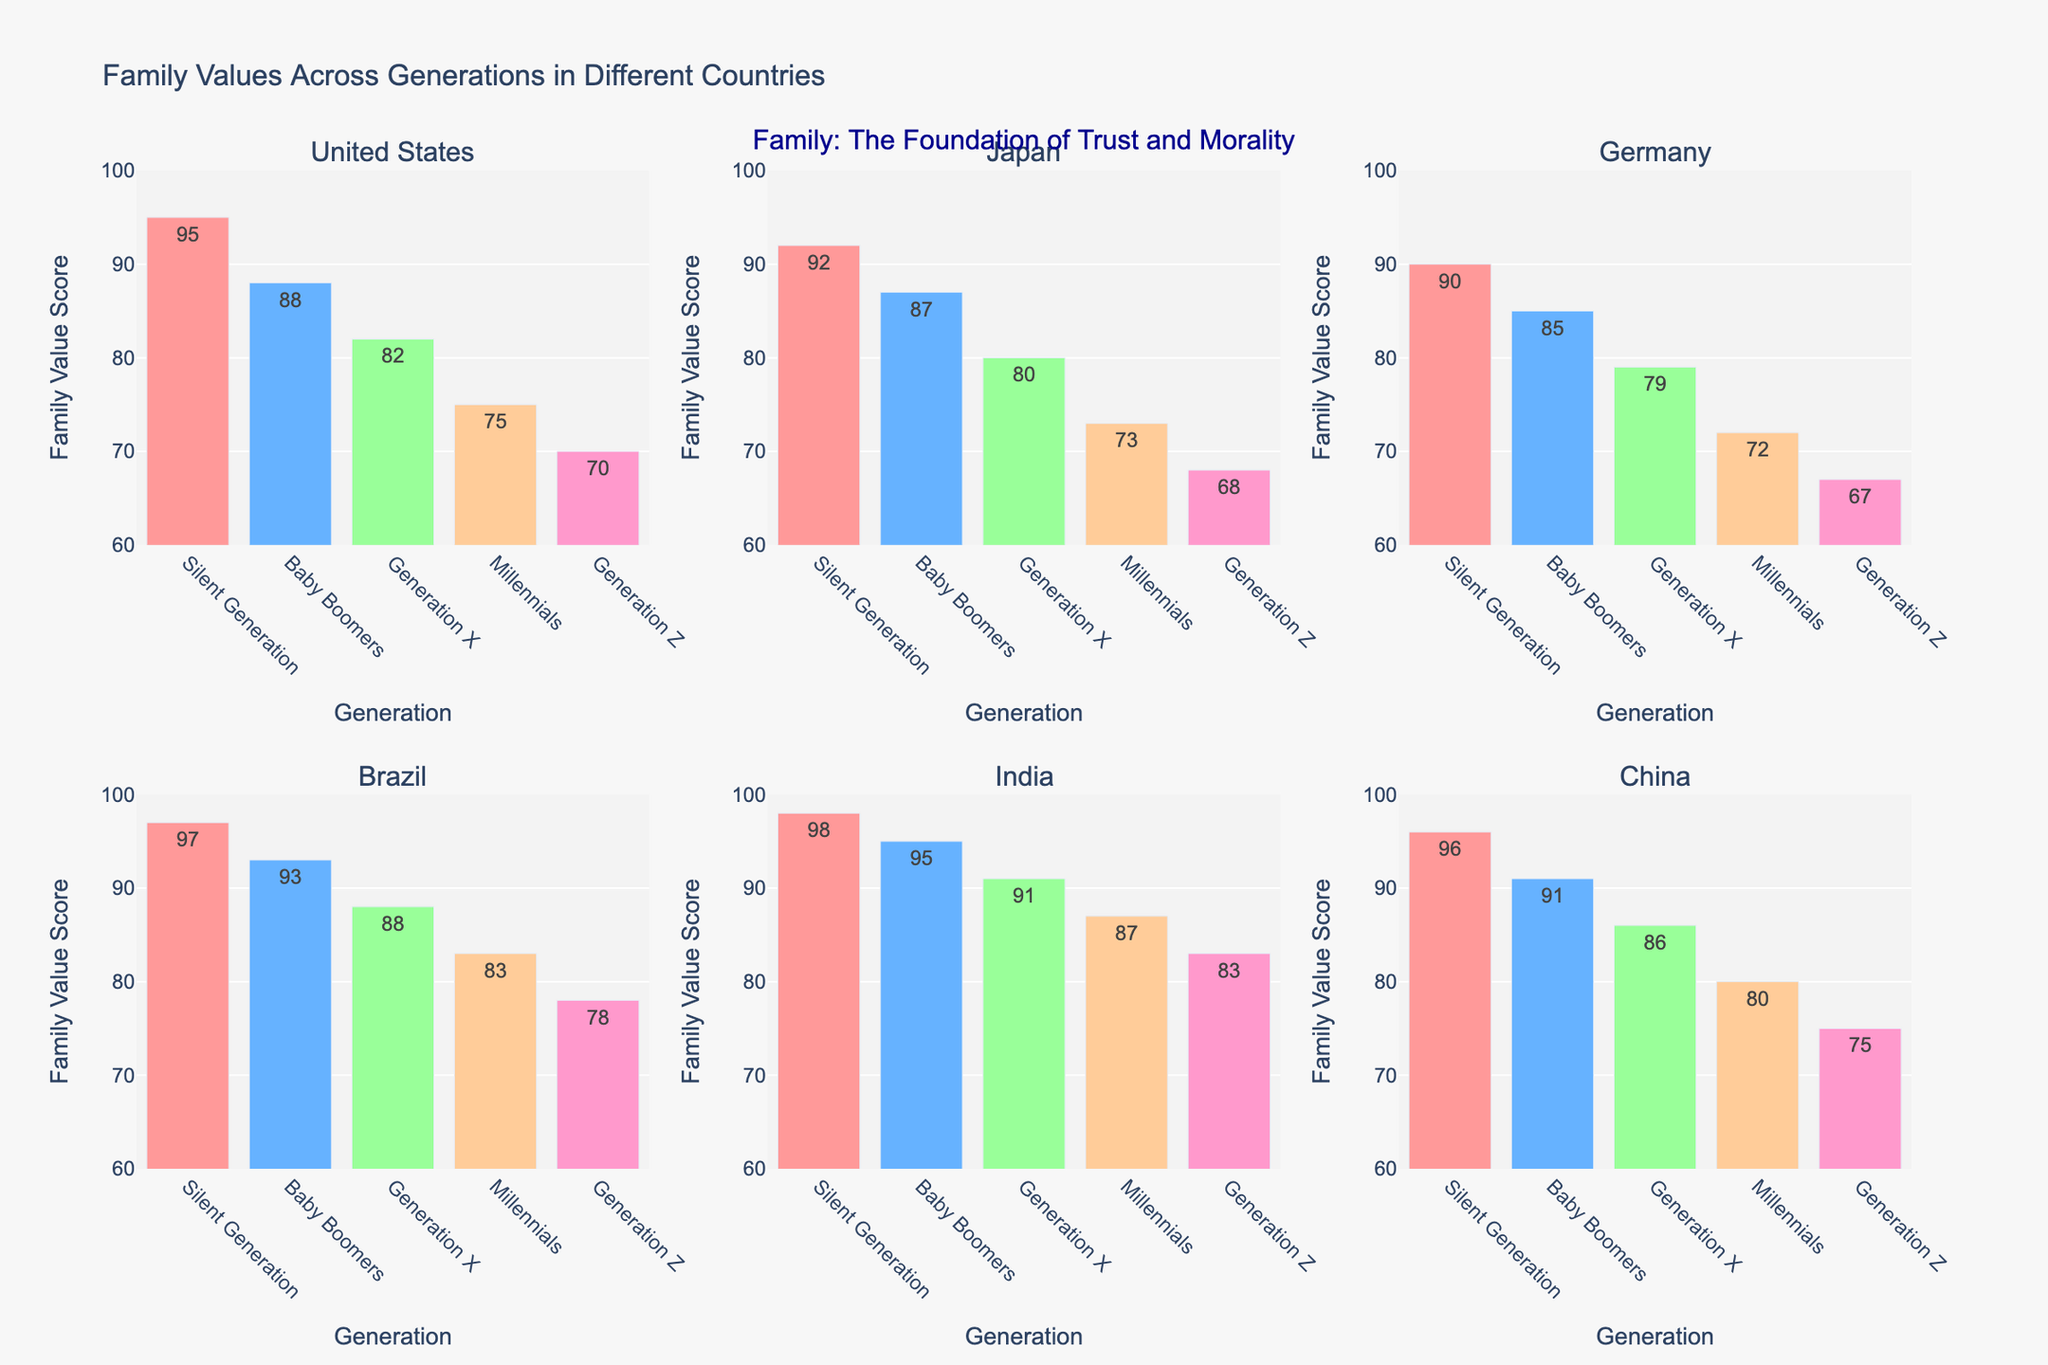Which generation in Brazil has the highest Family Value Score? The bar labeled "Silent Generation" in the subplot for Brazil is the tallest, indicating it has the highest Family Value Score.
Answer: Silent Generation Among all countries, which generation has the lowest Family Value Score? The bar for Generation Z in Germany is the shortest, indicating it has the lowest Family Value Score.
Answer: Generation Z in Germany Compare the Family Value Scores of Generation X in the United States and Japan. Which country has a higher score, and by how much? The bar for Generation X in the United States is at 82, and in Japan, it is at 80. The difference is 82 - 80 = 2.
Answer: United States, by 2 For India, what's the average Family Value Score across all generations? Sum the Family Value Scores for India: (98 + 95 + 91 + 87 + 83) = 454. Divide this sum by the number of generations, which is 5. So, the average is 454 / 5 = 90.8.
Answer: 90.8 Which country shows the greatest decrease in Family Value Score from the Silent Generation to Generation Z? Calculate the decrease for each country:  
- United States: 95 - 70 = 25
- Japan: 92 - 68 = 24
- Germany: 90 - 67 = 23
- Brazil: 97 - 78 = 19
- India: 98 - 83 = 15
- China: 96 - 75 = 21
The United States has the greatest decrease, which is 25.
Answer: United States What is the difference in Family Value Score between Baby Boomers and Millennials in Germany? The bar for Baby Boomers in Germany is at 85, and for Millennials, it is at 72. The difference is 85 - 72 = 13.
Answer: 13 Between Brazil and China, which country's Millennials have a higher Family Value Score, and what is the score difference? The bar for Millennials in Brazil is at 83, and in China, it is at 80. The difference is 83 - 80 = 3.
Answer: Brazil, by 3 In which country does the Generation Z bar have a Family Value Score closest to 70? The bar for Generation Z in the United States and China both show the nearest values to 70. China's Generation Z has a score at 75, which is closer to 70 than the other countries.
Answer: China If we combine the Family Value Scores of Baby Boomers in Japan and Germany, what would be their total score? Add the Family Value Scores of Baby Boomers in Japan (87) and Germany (85): 87 + 85 = 172.
Answer: 172 